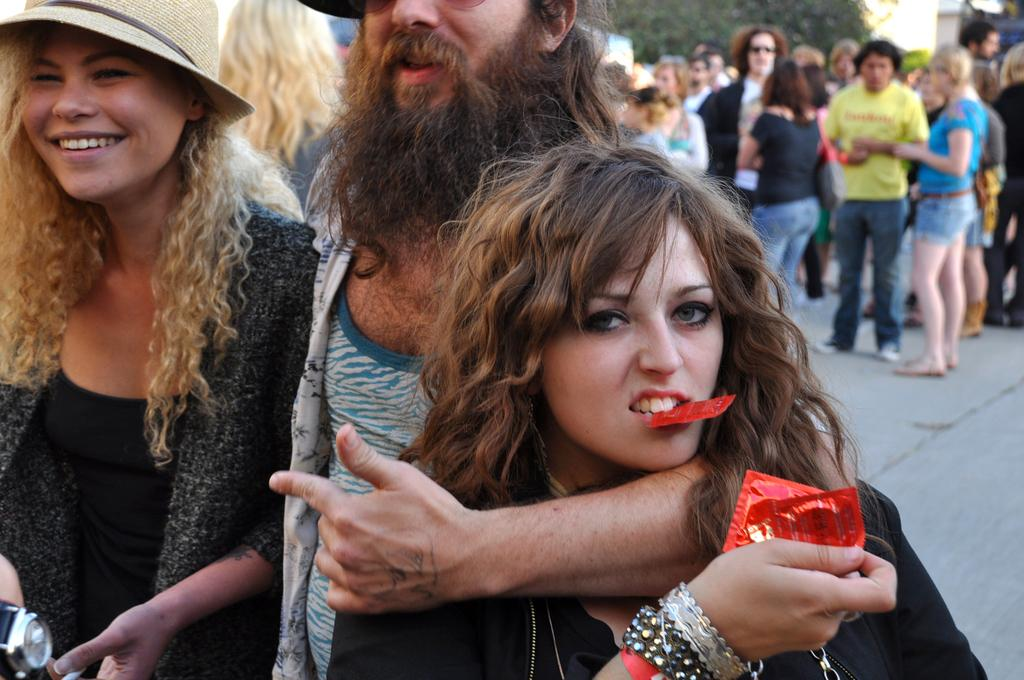How many people are in the image? There is a group of people in the image. What is the position of the people in the image? The people are standing on the ground. What is the woman holding in the image? The woman is holding covers. What can be seen in the background of the image? There is a tree visible in the background of the image. What type of thread is being used to sing songs in the image? There is no thread or singing in the image; it features a group of people standing on the ground with a woman holding covers and a tree in the background. 